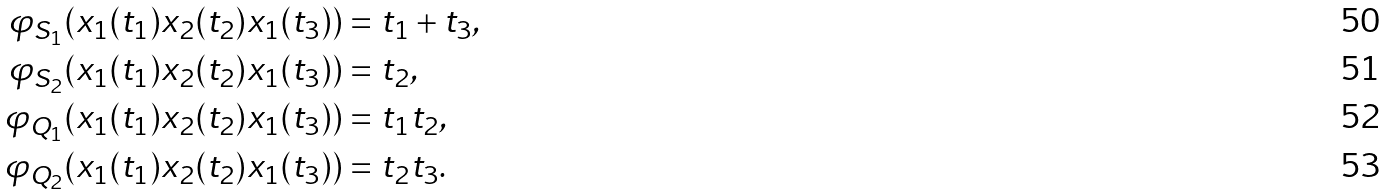<formula> <loc_0><loc_0><loc_500><loc_500>\varphi _ { S _ { 1 } } ( x _ { 1 } ( t _ { 1 } ) x _ { 2 } ( t _ { 2 } ) x _ { 1 } ( t _ { 3 } ) ) & = t _ { 1 } + t _ { 3 } , \\ \varphi _ { S _ { 2 } } ( x _ { 1 } ( t _ { 1 } ) x _ { 2 } ( t _ { 2 } ) x _ { 1 } ( t _ { 3 } ) ) & = t _ { 2 } , \\ \varphi _ { Q _ { 1 } } ( x _ { 1 } ( t _ { 1 } ) x _ { 2 } ( t _ { 2 } ) x _ { 1 } ( t _ { 3 } ) ) & = t _ { 1 } t _ { 2 } , \\ \varphi _ { Q _ { 2 } } ( x _ { 1 } ( t _ { 1 } ) x _ { 2 } ( t _ { 2 } ) x _ { 1 } ( t _ { 3 } ) ) & = t _ { 2 } t _ { 3 } .</formula> 